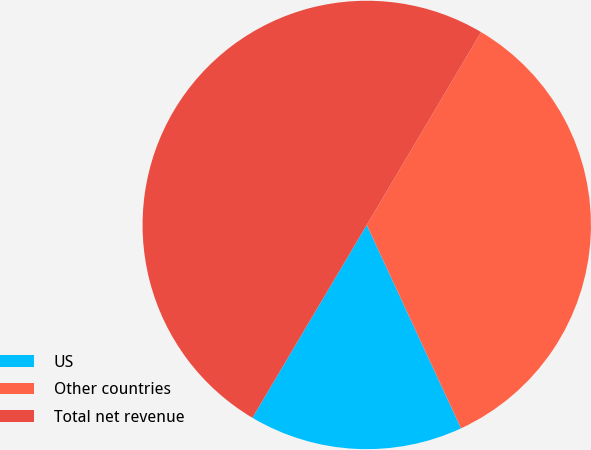Convert chart to OTSL. <chart><loc_0><loc_0><loc_500><loc_500><pie_chart><fcel>US<fcel>Other countries<fcel>Total net revenue<nl><fcel>15.43%<fcel>34.57%<fcel>50.0%<nl></chart> 